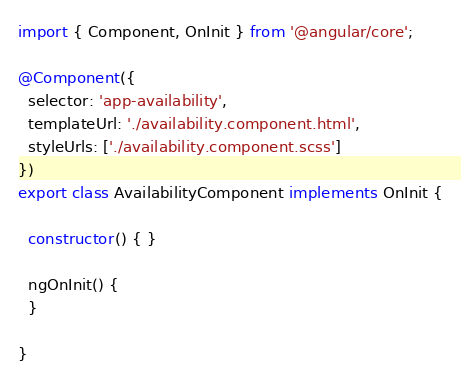Convert code to text. <code><loc_0><loc_0><loc_500><loc_500><_TypeScript_>import { Component, OnInit } from '@angular/core';

@Component({
  selector: 'app-availability',
  templateUrl: './availability.component.html',
  styleUrls: ['./availability.component.scss']
})
export class AvailabilityComponent implements OnInit {

  constructor() { }

  ngOnInit() {
  }

}
</code> 